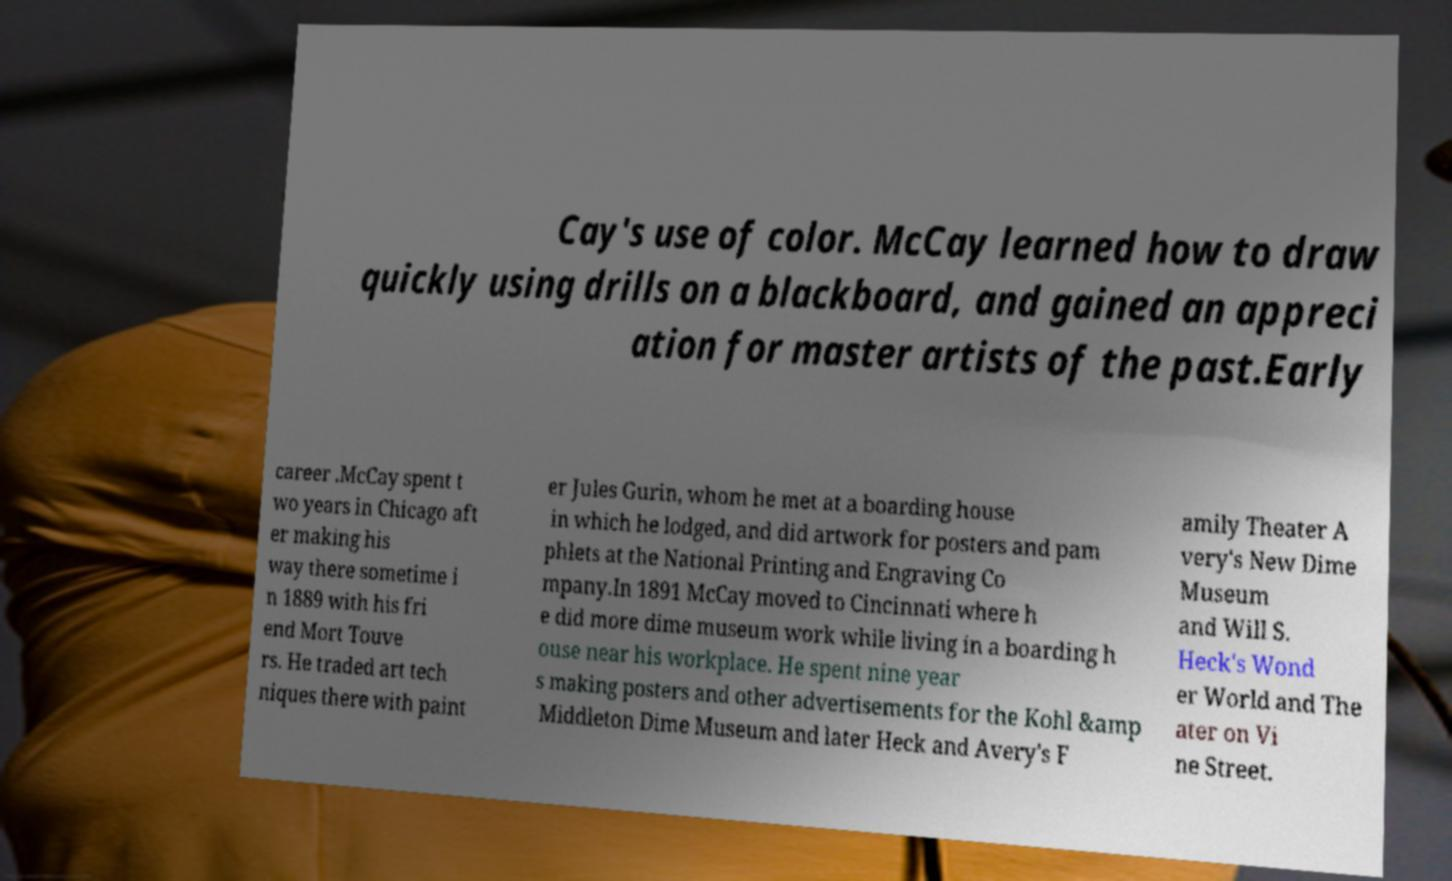Please identify and transcribe the text found in this image. Cay's use of color. McCay learned how to draw quickly using drills on a blackboard, and gained an appreci ation for master artists of the past.Early career .McCay spent t wo years in Chicago aft er making his way there sometime i n 1889 with his fri end Mort Touve rs. He traded art tech niques there with paint er Jules Gurin, whom he met at a boarding house in which he lodged, and did artwork for posters and pam phlets at the National Printing and Engraving Co mpany.In 1891 McCay moved to Cincinnati where h e did more dime museum work while living in a boarding h ouse near his workplace. He spent nine year s making posters and other advertisements for the Kohl &amp Middleton Dime Museum and later Heck and Avery's F amily Theater A very's New Dime Museum and Will S. Heck's Wond er World and The ater on Vi ne Street. 